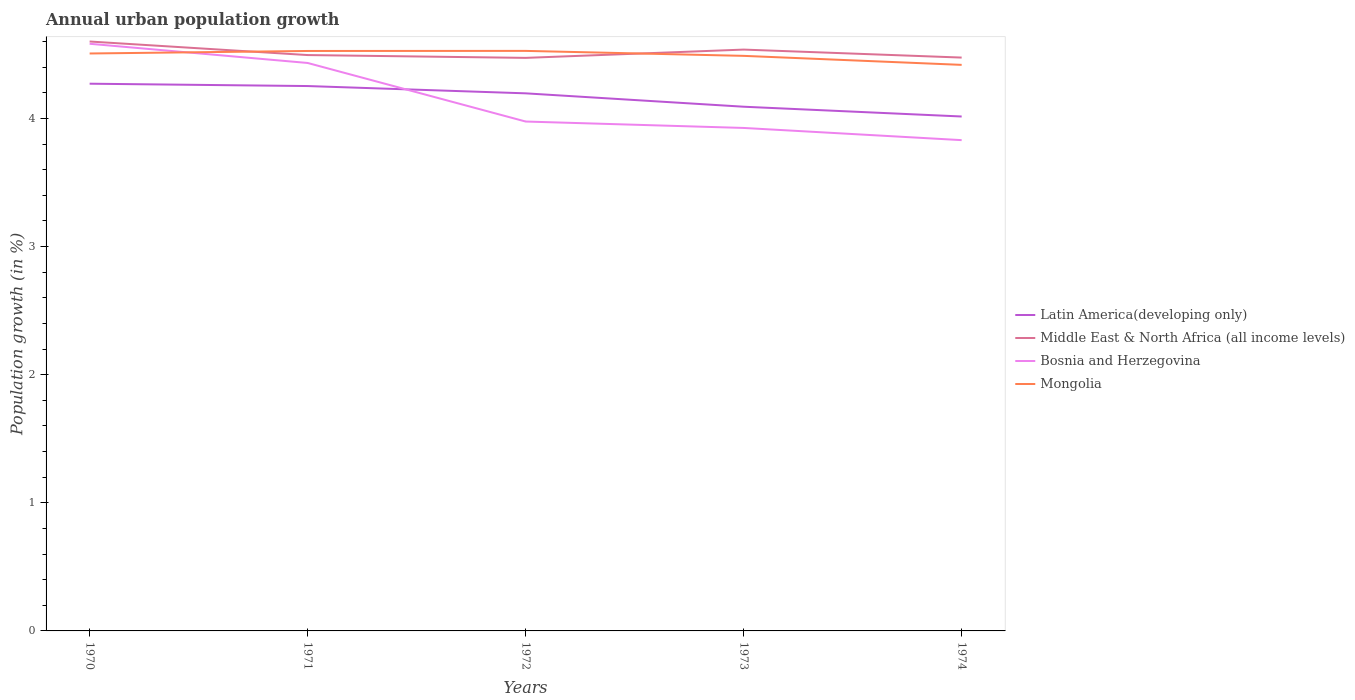Is the number of lines equal to the number of legend labels?
Keep it short and to the point. Yes. Across all years, what is the maximum percentage of urban population growth in Middle East & North Africa (all income levels)?
Provide a succinct answer. 4.47. In which year was the percentage of urban population growth in Mongolia maximum?
Give a very brief answer. 1974. What is the total percentage of urban population growth in Bosnia and Herzegovina in the graph?
Give a very brief answer. 0.6. What is the difference between the highest and the second highest percentage of urban population growth in Latin America(developing only)?
Make the answer very short. 0.26. What is the difference between the highest and the lowest percentage of urban population growth in Latin America(developing only)?
Provide a short and direct response. 3. How many lines are there?
Ensure brevity in your answer.  4. What is the difference between two consecutive major ticks on the Y-axis?
Ensure brevity in your answer.  1. How many legend labels are there?
Ensure brevity in your answer.  4. What is the title of the graph?
Offer a terse response. Annual urban population growth. What is the label or title of the Y-axis?
Your answer should be very brief. Population growth (in %). What is the Population growth (in %) in Latin America(developing only) in 1970?
Offer a terse response. 4.27. What is the Population growth (in %) of Middle East & North Africa (all income levels) in 1970?
Keep it short and to the point. 4.6. What is the Population growth (in %) of Bosnia and Herzegovina in 1970?
Provide a short and direct response. 4.58. What is the Population growth (in %) in Mongolia in 1970?
Offer a terse response. 4.51. What is the Population growth (in %) in Latin America(developing only) in 1971?
Your response must be concise. 4.25. What is the Population growth (in %) in Middle East & North Africa (all income levels) in 1971?
Your response must be concise. 4.49. What is the Population growth (in %) in Bosnia and Herzegovina in 1971?
Provide a short and direct response. 4.43. What is the Population growth (in %) of Mongolia in 1971?
Offer a very short reply. 4.53. What is the Population growth (in %) of Latin America(developing only) in 1972?
Provide a short and direct response. 4.2. What is the Population growth (in %) in Middle East & North Africa (all income levels) in 1972?
Provide a short and direct response. 4.47. What is the Population growth (in %) in Bosnia and Herzegovina in 1972?
Offer a very short reply. 3.98. What is the Population growth (in %) in Mongolia in 1972?
Make the answer very short. 4.53. What is the Population growth (in %) of Latin America(developing only) in 1973?
Make the answer very short. 4.09. What is the Population growth (in %) of Middle East & North Africa (all income levels) in 1973?
Your answer should be very brief. 4.54. What is the Population growth (in %) in Bosnia and Herzegovina in 1973?
Provide a succinct answer. 3.93. What is the Population growth (in %) in Mongolia in 1973?
Offer a terse response. 4.49. What is the Population growth (in %) in Latin America(developing only) in 1974?
Make the answer very short. 4.01. What is the Population growth (in %) in Middle East & North Africa (all income levels) in 1974?
Offer a terse response. 4.47. What is the Population growth (in %) in Bosnia and Herzegovina in 1974?
Provide a succinct answer. 3.83. What is the Population growth (in %) of Mongolia in 1974?
Make the answer very short. 4.42. Across all years, what is the maximum Population growth (in %) of Latin America(developing only)?
Keep it short and to the point. 4.27. Across all years, what is the maximum Population growth (in %) of Middle East & North Africa (all income levels)?
Your answer should be very brief. 4.6. Across all years, what is the maximum Population growth (in %) in Bosnia and Herzegovina?
Give a very brief answer. 4.58. Across all years, what is the maximum Population growth (in %) of Mongolia?
Make the answer very short. 4.53. Across all years, what is the minimum Population growth (in %) of Latin America(developing only)?
Provide a short and direct response. 4.01. Across all years, what is the minimum Population growth (in %) of Middle East & North Africa (all income levels)?
Provide a short and direct response. 4.47. Across all years, what is the minimum Population growth (in %) of Bosnia and Herzegovina?
Your response must be concise. 3.83. Across all years, what is the minimum Population growth (in %) of Mongolia?
Your answer should be compact. 4.42. What is the total Population growth (in %) in Latin America(developing only) in the graph?
Provide a short and direct response. 20.83. What is the total Population growth (in %) in Middle East & North Africa (all income levels) in the graph?
Offer a terse response. 22.58. What is the total Population growth (in %) of Bosnia and Herzegovina in the graph?
Your answer should be compact. 20.75. What is the total Population growth (in %) of Mongolia in the graph?
Your response must be concise. 22.47. What is the difference between the Population growth (in %) of Latin America(developing only) in 1970 and that in 1971?
Ensure brevity in your answer.  0.02. What is the difference between the Population growth (in %) of Middle East & North Africa (all income levels) in 1970 and that in 1971?
Make the answer very short. 0.11. What is the difference between the Population growth (in %) in Bosnia and Herzegovina in 1970 and that in 1971?
Offer a terse response. 0.15. What is the difference between the Population growth (in %) in Mongolia in 1970 and that in 1971?
Keep it short and to the point. -0.02. What is the difference between the Population growth (in %) in Latin America(developing only) in 1970 and that in 1972?
Offer a very short reply. 0.08. What is the difference between the Population growth (in %) of Middle East & North Africa (all income levels) in 1970 and that in 1972?
Give a very brief answer. 0.13. What is the difference between the Population growth (in %) in Bosnia and Herzegovina in 1970 and that in 1972?
Keep it short and to the point. 0.61. What is the difference between the Population growth (in %) in Mongolia in 1970 and that in 1972?
Your answer should be compact. -0.02. What is the difference between the Population growth (in %) in Latin America(developing only) in 1970 and that in 1973?
Provide a short and direct response. 0.18. What is the difference between the Population growth (in %) in Middle East & North Africa (all income levels) in 1970 and that in 1973?
Provide a short and direct response. 0.06. What is the difference between the Population growth (in %) of Bosnia and Herzegovina in 1970 and that in 1973?
Give a very brief answer. 0.66. What is the difference between the Population growth (in %) in Mongolia in 1970 and that in 1973?
Provide a succinct answer. 0.02. What is the difference between the Population growth (in %) in Latin America(developing only) in 1970 and that in 1974?
Keep it short and to the point. 0.26. What is the difference between the Population growth (in %) of Middle East & North Africa (all income levels) in 1970 and that in 1974?
Your answer should be very brief. 0.13. What is the difference between the Population growth (in %) of Bosnia and Herzegovina in 1970 and that in 1974?
Your response must be concise. 0.75. What is the difference between the Population growth (in %) of Mongolia in 1970 and that in 1974?
Keep it short and to the point. 0.09. What is the difference between the Population growth (in %) of Latin America(developing only) in 1971 and that in 1972?
Ensure brevity in your answer.  0.06. What is the difference between the Population growth (in %) in Middle East & North Africa (all income levels) in 1971 and that in 1972?
Give a very brief answer. 0.02. What is the difference between the Population growth (in %) of Bosnia and Herzegovina in 1971 and that in 1972?
Offer a very short reply. 0.46. What is the difference between the Population growth (in %) of Mongolia in 1971 and that in 1972?
Your answer should be compact. -0. What is the difference between the Population growth (in %) of Latin America(developing only) in 1971 and that in 1973?
Provide a short and direct response. 0.16. What is the difference between the Population growth (in %) of Middle East & North Africa (all income levels) in 1971 and that in 1973?
Keep it short and to the point. -0.04. What is the difference between the Population growth (in %) of Bosnia and Herzegovina in 1971 and that in 1973?
Make the answer very short. 0.51. What is the difference between the Population growth (in %) of Mongolia in 1971 and that in 1973?
Keep it short and to the point. 0.04. What is the difference between the Population growth (in %) in Latin America(developing only) in 1971 and that in 1974?
Ensure brevity in your answer.  0.24. What is the difference between the Population growth (in %) in Middle East & North Africa (all income levels) in 1971 and that in 1974?
Your response must be concise. 0.02. What is the difference between the Population growth (in %) of Bosnia and Herzegovina in 1971 and that in 1974?
Your response must be concise. 0.6. What is the difference between the Population growth (in %) of Mongolia in 1971 and that in 1974?
Your answer should be very brief. 0.11. What is the difference between the Population growth (in %) in Latin America(developing only) in 1972 and that in 1973?
Make the answer very short. 0.1. What is the difference between the Population growth (in %) in Middle East & North Africa (all income levels) in 1972 and that in 1973?
Ensure brevity in your answer.  -0.06. What is the difference between the Population growth (in %) of Mongolia in 1972 and that in 1973?
Give a very brief answer. 0.04. What is the difference between the Population growth (in %) of Latin America(developing only) in 1972 and that in 1974?
Your response must be concise. 0.18. What is the difference between the Population growth (in %) of Middle East & North Africa (all income levels) in 1972 and that in 1974?
Ensure brevity in your answer.  -0. What is the difference between the Population growth (in %) in Bosnia and Herzegovina in 1972 and that in 1974?
Your response must be concise. 0.15. What is the difference between the Population growth (in %) in Mongolia in 1972 and that in 1974?
Ensure brevity in your answer.  0.11. What is the difference between the Population growth (in %) in Latin America(developing only) in 1973 and that in 1974?
Make the answer very short. 0.08. What is the difference between the Population growth (in %) in Middle East & North Africa (all income levels) in 1973 and that in 1974?
Offer a terse response. 0.06. What is the difference between the Population growth (in %) of Bosnia and Herzegovina in 1973 and that in 1974?
Make the answer very short. 0.1. What is the difference between the Population growth (in %) of Mongolia in 1973 and that in 1974?
Give a very brief answer. 0.07. What is the difference between the Population growth (in %) in Latin America(developing only) in 1970 and the Population growth (in %) in Middle East & North Africa (all income levels) in 1971?
Ensure brevity in your answer.  -0.22. What is the difference between the Population growth (in %) of Latin America(developing only) in 1970 and the Population growth (in %) of Bosnia and Herzegovina in 1971?
Provide a short and direct response. -0.16. What is the difference between the Population growth (in %) of Latin America(developing only) in 1970 and the Population growth (in %) of Mongolia in 1971?
Make the answer very short. -0.26. What is the difference between the Population growth (in %) in Middle East & North Africa (all income levels) in 1970 and the Population growth (in %) in Bosnia and Herzegovina in 1971?
Ensure brevity in your answer.  0.17. What is the difference between the Population growth (in %) of Middle East & North Africa (all income levels) in 1970 and the Population growth (in %) of Mongolia in 1971?
Offer a very short reply. 0.07. What is the difference between the Population growth (in %) in Bosnia and Herzegovina in 1970 and the Population growth (in %) in Mongolia in 1971?
Your answer should be compact. 0.06. What is the difference between the Population growth (in %) in Latin America(developing only) in 1970 and the Population growth (in %) in Middle East & North Africa (all income levels) in 1972?
Your response must be concise. -0.2. What is the difference between the Population growth (in %) in Latin America(developing only) in 1970 and the Population growth (in %) in Bosnia and Herzegovina in 1972?
Make the answer very short. 0.3. What is the difference between the Population growth (in %) of Latin America(developing only) in 1970 and the Population growth (in %) of Mongolia in 1972?
Your answer should be compact. -0.26. What is the difference between the Population growth (in %) in Middle East & North Africa (all income levels) in 1970 and the Population growth (in %) in Bosnia and Herzegovina in 1972?
Your response must be concise. 0.62. What is the difference between the Population growth (in %) in Middle East & North Africa (all income levels) in 1970 and the Population growth (in %) in Mongolia in 1972?
Make the answer very short. 0.07. What is the difference between the Population growth (in %) of Bosnia and Herzegovina in 1970 and the Population growth (in %) of Mongolia in 1972?
Provide a succinct answer. 0.06. What is the difference between the Population growth (in %) in Latin America(developing only) in 1970 and the Population growth (in %) in Middle East & North Africa (all income levels) in 1973?
Make the answer very short. -0.27. What is the difference between the Population growth (in %) in Latin America(developing only) in 1970 and the Population growth (in %) in Bosnia and Herzegovina in 1973?
Make the answer very short. 0.35. What is the difference between the Population growth (in %) of Latin America(developing only) in 1970 and the Population growth (in %) of Mongolia in 1973?
Give a very brief answer. -0.22. What is the difference between the Population growth (in %) in Middle East & North Africa (all income levels) in 1970 and the Population growth (in %) in Bosnia and Herzegovina in 1973?
Offer a terse response. 0.67. What is the difference between the Population growth (in %) of Middle East & North Africa (all income levels) in 1970 and the Population growth (in %) of Mongolia in 1973?
Ensure brevity in your answer.  0.11. What is the difference between the Population growth (in %) of Bosnia and Herzegovina in 1970 and the Population growth (in %) of Mongolia in 1973?
Make the answer very short. 0.09. What is the difference between the Population growth (in %) in Latin America(developing only) in 1970 and the Population growth (in %) in Middle East & North Africa (all income levels) in 1974?
Ensure brevity in your answer.  -0.2. What is the difference between the Population growth (in %) of Latin America(developing only) in 1970 and the Population growth (in %) of Bosnia and Herzegovina in 1974?
Your answer should be compact. 0.44. What is the difference between the Population growth (in %) in Latin America(developing only) in 1970 and the Population growth (in %) in Mongolia in 1974?
Your answer should be very brief. -0.15. What is the difference between the Population growth (in %) in Middle East & North Africa (all income levels) in 1970 and the Population growth (in %) in Bosnia and Herzegovina in 1974?
Provide a short and direct response. 0.77. What is the difference between the Population growth (in %) of Middle East & North Africa (all income levels) in 1970 and the Population growth (in %) of Mongolia in 1974?
Your answer should be compact. 0.18. What is the difference between the Population growth (in %) of Bosnia and Herzegovina in 1970 and the Population growth (in %) of Mongolia in 1974?
Provide a short and direct response. 0.16. What is the difference between the Population growth (in %) in Latin America(developing only) in 1971 and the Population growth (in %) in Middle East & North Africa (all income levels) in 1972?
Ensure brevity in your answer.  -0.22. What is the difference between the Population growth (in %) in Latin America(developing only) in 1971 and the Population growth (in %) in Bosnia and Herzegovina in 1972?
Offer a very short reply. 0.28. What is the difference between the Population growth (in %) in Latin America(developing only) in 1971 and the Population growth (in %) in Mongolia in 1972?
Provide a short and direct response. -0.27. What is the difference between the Population growth (in %) in Middle East & North Africa (all income levels) in 1971 and the Population growth (in %) in Bosnia and Herzegovina in 1972?
Give a very brief answer. 0.52. What is the difference between the Population growth (in %) of Middle East & North Africa (all income levels) in 1971 and the Population growth (in %) of Mongolia in 1972?
Your answer should be compact. -0.03. What is the difference between the Population growth (in %) in Bosnia and Herzegovina in 1971 and the Population growth (in %) in Mongolia in 1972?
Offer a very short reply. -0.09. What is the difference between the Population growth (in %) of Latin America(developing only) in 1971 and the Population growth (in %) of Middle East & North Africa (all income levels) in 1973?
Offer a terse response. -0.28. What is the difference between the Population growth (in %) in Latin America(developing only) in 1971 and the Population growth (in %) in Bosnia and Herzegovina in 1973?
Provide a succinct answer. 0.33. What is the difference between the Population growth (in %) in Latin America(developing only) in 1971 and the Population growth (in %) in Mongolia in 1973?
Keep it short and to the point. -0.24. What is the difference between the Population growth (in %) of Middle East & North Africa (all income levels) in 1971 and the Population growth (in %) of Bosnia and Herzegovina in 1973?
Give a very brief answer. 0.57. What is the difference between the Population growth (in %) of Middle East & North Africa (all income levels) in 1971 and the Population growth (in %) of Mongolia in 1973?
Your answer should be very brief. 0.01. What is the difference between the Population growth (in %) of Bosnia and Herzegovina in 1971 and the Population growth (in %) of Mongolia in 1973?
Your answer should be compact. -0.06. What is the difference between the Population growth (in %) of Latin America(developing only) in 1971 and the Population growth (in %) of Middle East & North Africa (all income levels) in 1974?
Your response must be concise. -0.22. What is the difference between the Population growth (in %) in Latin America(developing only) in 1971 and the Population growth (in %) in Bosnia and Herzegovina in 1974?
Provide a succinct answer. 0.42. What is the difference between the Population growth (in %) in Latin America(developing only) in 1971 and the Population growth (in %) in Mongolia in 1974?
Offer a terse response. -0.17. What is the difference between the Population growth (in %) of Middle East & North Africa (all income levels) in 1971 and the Population growth (in %) of Bosnia and Herzegovina in 1974?
Offer a terse response. 0.66. What is the difference between the Population growth (in %) of Middle East & North Africa (all income levels) in 1971 and the Population growth (in %) of Mongolia in 1974?
Make the answer very short. 0.08. What is the difference between the Population growth (in %) in Bosnia and Herzegovina in 1971 and the Population growth (in %) in Mongolia in 1974?
Your answer should be compact. 0.01. What is the difference between the Population growth (in %) of Latin America(developing only) in 1972 and the Population growth (in %) of Middle East & North Africa (all income levels) in 1973?
Your answer should be very brief. -0.34. What is the difference between the Population growth (in %) in Latin America(developing only) in 1972 and the Population growth (in %) in Bosnia and Herzegovina in 1973?
Keep it short and to the point. 0.27. What is the difference between the Population growth (in %) in Latin America(developing only) in 1972 and the Population growth (in %) in Mongolia in 1973?
Offer a terse response. -0.29. What is the difference between the Population growth (in %) in Middle East & North Africa (all income levels) in 1972 and the Population growth (in %) in Bosnia and Herzegovina in 1973?
Ensure brevity in your answer.  0.55. What is the difference between the Population growth (in %) of Middle East & North Africa (all income levels) in 1972 and the Population growth (in %) of Mongolia in 1973?
Offer a very short reply. -0.02. What is the difference between the Population growth (in %) of Bosnia and Herzegovina in 1972 and the Population growth (in %) of Mongolia in 1973?
Provide a short and direct response. -0.51. What is the difference between the Population growth (in %) in Latin America(developing only) in 1972 and the Population growth (in %) in Middle East & North Africa (all income levels) in 1974?
Provide a short and direct response. -0.28. What is the difference between the Population growth (in %) in Latin America(developing only) in 1972 and the Population growth (in %) in Bosnia and Herzegovina in 1974?
Ensure brevity in your answer.  0.37. What is the difference between the Population growth (in %) of Latin America(developing only) in 1972 and the Population growth (in %) of Mongolia in 1974?
Offer a terse response. -0.22. What is the difference between the Population growth (in %) in Middle East & North Africa (all income levels) in 1972 and the Population growth (in %) in Bosnia and Herzegovina in 1974?
Give a very brief answer. 0.64. What is the difference between the Population growth (in %) in Middle East & North Africa (all income levels) in 1972 and the Population growth (in %) in Mongolia in 1974?
Ensure brevity in your answer.  0.05. What is the difference between the Population growth (in %) of Bosnia and Herzegovina in 1972 and the Population growth (in %) of Mongolia in 1974?
Provide a succinct answer. -0.44. What is the difference between the Population growth (in %) in Latin America(developing only) in 1973 and the Population growth (in %) in Middle East & North Africa (all income levels) in 1974?
Provide a short and direct response. -0.38. What is the difference between the Population growth (in %) in Latin America(developing only) in 1973 and the Population growth (in %) in Bosnia and Herzegovina in 1974?
Give a very brief answer. 0.26. What is the difference between the Population growth (in %) in Latin America(developing only) in 1973 and the Population growth (in %) in Mongolia in 1974?
Your answer should be compact. -0.33. What is the difference between the Population growth (in %) in Middle East & North Africa (all income levels) in 1973 and the Population growth (in %) in Bosnia and Herzegovina in 1974?
Provide a succinct answer. 0.71. What is the difference between the Population growth (in %) of Middle East & North Africa (all income levels) in 1973 and the Population growth (in %) of Mongolia in 1974?
Provide a succinct answer. 0.12. What is the difference between the Population growth (in %) of Bosnia and Herzegovina in 1973 and the Population growth (in %) of Mongolia in 1974?
Make the answer very short. -0.49. What is the average Population growth (in %) in Latin America(developing only) per year?
Offer a terse response. 4.17. What is the average Population growth (in %) of Middle East & North Africa (all income levels) per year?
Keep it short and to the point. 4.52. What is the average Population growth (in %) of Bosnia and Herzegovina per year?
Keep it short and to the point. 4.15. What is the average Population growth (in %) of Mongolia per year?
Provide a succinct answer. 4.49. In the year 1970, what is the difference between the Population growth (in %) in Latin America(developing only) and Population growth (in %) in Middle East & North Africa (all income levels)?
Your answer should be compact. -0.33. In the year 1970, what is the difference between the Population growth (in %) of Latin America(developing only) and Population growth (in %) of Bosnia and Herzegovina?
Keep it short and to the point. -0.31. In the year 1970, what is the difference between the Population growth (in %) of Latin America(developing only) and Population growth (in %) of Mongolia?
Offer a terse response. -0.24. In the year 1970, what is the difference between the Population growth (in %) of Middle East & North Africa (all income levels) and Population growth (in %) of Bosnia and Herzegovina?
Provide a succinct answer. 0.02. In the year 1970, what is the difference between the Population growth (in %) of Middle East & North Africa (all income levels) and Population growth (in %) of Mongolia?
Offer a terse response. 0.09. In the year 1970, what is the difference between the Population growth (in %) in Bosnia and Herzegovina and Population growth (in %) in Mongolia?
Your response must be concise. 0.08. In the year 1971, what is the difference between the Population growth (in %) in Latin America(developing only) and Population growth (in %) in Middle East & North Africa (all income levels)?
Offer a terse response. -0.24. In the year 1971, what is the difference between the Population growth (in %) of Latin America(developing only) and Population growth (in %) of Bosnia and Herzegovina?
Your answer should be compact. -0.18. In the year 1971, what is the difference between the Population growth (in %) in Latin America(developing only) and Population growth (in %) in Mongolia?
Your answer should be compact. -0.27. In the year 1971, what is the difference between the Population growth (in %) in Middle East & North Africa (all income levels) and Population growth (in %) in Bosnia and Herzegovina?
Offer a very short reply. 0.06. In the year 1971, what is the difference between the Population growth (in %) in Middle East & North Africa (all income levels) and Population growth (in %) in Mongolia?
Keep it short and to the point. -0.03. In the year 1971, what is the difference between the Population growth (in %) of Bosnia and Herzegovina and Population growth (in %) of Mongolia?
Make the answer very short. -0.09. In the year 1972, what is the difference between the Population growth (in %) in Latin America(developing only) and Population growth (in %) in Middle East & North Africa (all income levels)?
Your answer should be compact. -0.28. In the year 1972, what is the difference between the Population growth (in %) in Latin America(developing only) and Population growth (in %) in Bosnia and Herzegovina?
Offer a very short reply. 0.22. In the year 1972, what is the difference between the Population growth (in %) of Latin America(developing only) and Population growth (in %) of Mongolia?
Offer a very short reply. -0.33. In the year 1972, what is the difference between the Population growth (in %) in Middle East & North Africa (all income levels) and Population growth (in %) in Bosnia and Herzegovina?
Your response must be concise. 0.5. In the year 1972, what is the difference between the Population growth (in %) in Middle East & North Africa (all income levels) and Population growth (in %) in Mongolia?
Ensure brevity in your answer.  -0.05. In the year 1972, what is the difference between the Population growth (in %) of Bosnia and Herzegovina and Population growth (in %) of Mongolia?
Offer a terse response. -0.55. In the year 1973, what is the difference between the Population growth (in %) in Latin America(developing only) and Population growth (in %) in Middle East & North Africa (all income levels)?
Your answer should be very brief. -0.45. In the year 1973, what is the difference between the Population growth (in %) of Latin America(developing only) and Population growth (in %) of Bosnia and Herzegovina?
Your answer should be very brief. 0.17. In the year 1973, what is the difference between the Population growth (in %) of Latin America(developing only) and Population growth (in %) of Mongolia?
Provide a succinct answer. -0.4. In the year 1973, what is the difference between the Population growth (in %) in Middle East & North Africa (all income levels) and Population growth (in %) in Bosnia and Herzegovina?
Your answer should be very brief. 0.61. In the year 1973, what is the difference between the Population growth (in %) in Middle East & North Africa (all income levels) and Population growth (in %) in Mongolia?
Keep it short and to the point. 0.05. In the year 1973, what is the difference between the Population growth (in %) in Bosnia and Herzegovina and Population growth (in %) in Mongolia?
Provide a short and direct response. -0.56. In the year 1974, what is the difference between the Population growth (in %) in Latin America(developing only) and Population growth (in %) in Middle East & North Africa (all income levels)?
Keep it short and to the point. -0.46. In the year 1974, what is the difference between the Population growth (in %) of Latin America(developing only) and Population growth (in %) of Bosnia and Herzegovina?
Your answer should be very brief. 0.18. In the year 1974, what is the difference between the Population growth (in %) of Latin America(developing only) and Population growth (in %) of Mongolia?
Offer a terse response. -0.4. In the year 1974, what is the difference between the Population growth (in %) in Middle East & North Africa (all income levels) and Population growth (in %) in Bosnia and Herzegovina?
Keep it short and to the point. 0.64. In the year 1974, what is the difference between the Population growth (in %) of Middle East & North Africa (all income levels) and Population growth (in %) of Mongolia?
Keep it short and to the point. 0.06. In the year 1974, what is the difference between the Population growth (in %) in Bosnia and Herzegovina and Population growth (in %) in Mongolia?
Your answer should be compact. -0.59. What is the ratio of the Population growth (in %) in Latin America(developing only) in 1970 to that in 1971?
Your answer should be compact. 1. What is the ratio of the Population growth (in %) of Middle East & North Africa (all income levels) in 1970 to that in 1971?
Give a very brief answer. 1.02. What is the ratio of the Population growth (in %) of Bosnia and Herzegovina in 1970 to that in 1971?
Ensure brevity in your answer.  1.03. What is the ratio of the Population growth (in %) of Latin America(developing only) in 1970 to that in 1972?
Provide a short and direct response. 1.02. What is the ratio of the Population growth (in %) of Middle East & North Africa (all income levels) in 1970 to that in 1972?
Offer a very short reply. 1.03. What is the ratio of the Population growth (in %) in Bosnia and Herzegovina in 1970 to that in 1972?
Offer a very short reply. 1.15. What is the ratio of the Population growth (in %) of Mongolia in 1970 to that in 1972?
Provide a succinct answer. 1. What is the ratio of the Population growth (in %) in Latin America(developing only) in 1970 to that in 1973?
Make the answer very short. 1.04. What is the ratio of the Population growth (in %) of Middle East & North Africa (all income levels) in 1970 to that in 1973?
Keep it short and to the point. 1.01. What is the ratio of the Population growth (in %) of Bosnia and Herzegovina in 1970 to that in 1973?
Keep it short and to the point. 1.17. What is the ratio of the Population growth (in %) of Latin America(developing only) in 1970 to that in 1974?
Provide a succinct answer. 1.06. What is the ratio of the Population growth (in %) in Middle East & North Africa (all income levels) in 1970 to that in 1974?
Your response must be concise. 1.03. What is the ratio of the Population growth (in %) in Bosnia and Herzegovina in 1970 to that in 1974?
Give a very brief answer. 1.2. What is the ratio of the Population growth (in %) in Mongolia in 1970 to that in 1974?
Your answer should be compact. 1.02. What is the ratio of the Population growth (in %) in Latin America(developing only) in 1971 to that in 1972?
Your answer should be very brief. 1.01. What is the ratio of the Population growth (in %) in Middle East & North Africa (all income levels) in 1971 to that in 1972?
Ensure brevity in your answer.  1. What is the ratio of the Population growth (in %) in Bosnia and Herzegovina in 1971 to that in 1972?
Your answer should be very brief. 1.11. What is the ratio of the Population growth (in %) in Latin America(developing only) in 1971 to that in 1973?
Ensure brevity in your answer.  1.04. What is the ratio of the Population growth (in %) in Middle East & North Africa (all income levels) in 1971 to that in 1973?
Ensure brevity in your answer.  0.99. What is the ratio of the Population growth (in %) of Bosnia and Herzegovina in 1971 to that in 1973?
Offer a very short reply. 1.13. What is the ratio of the Population growth (in %) of Mongolia in 1971 to that in 1973?
Provide a short and direct response. 1.01. What is the ratio of the Population growth (in %) in Latin America(developing only) in 1971 to that in 1974?
Offer a very short reply. 1.06. What is the ratio of the Population growth (in %) in Bosnia and Herzegovina in 1971 to that in 1974?
Provide a short and direct response. 1.16. What is the ratio of the Population growth (in %) in Mongolia in 1971 to that in 1974?
Make the answer very short. 1.02. What is the ratio of the Population growth (in %) of Latin America(developing only) in 1972 to that in 1973?
Your answer should be very brief. 1.03. What is the ratio of the Population growth (in %) in Middle East & North Africa (all income levels) in 1972 to that in 1973?
Your answer should be compact. 0.99. What is the ratio of the Population growth (in %) in Bosnia and Herzegovina in 1972 to that in 1973?
Offer a terse response. 1.01. What is the ratio of the Population growth (in %) in Mongolia in 1972 to that in 1973?
Provide a short and direct response. 1.01. What is the ratio of the Population growth (in %) in Latin America(developing only) in 1972 to that in 1974?
Your answer should be compact. 1.04. What is the ratio of the Population growth (in %) of Bosnia and Herzegovina in 1972 to that in 1974?
Offer a terse response. 1.04. What is the ratio of the Population growth (in %) in Mongolia in 1972 to that in 1974?
Your answer should be very brief. 1.02. What is the ratio of the Population growth (in %) in Latin America(developing only) in 1973 to that in 1974?
Offer a very short reply. 1.02. What is the ratio of the Population growth (in %) of Middle East & North Africa (all income levels) in 1973 to that in 1974?
Give a very brief answer. 1.01. What is the ratio of the Population growth (in %) in Bosnia and Herzegovina in 1973 to that in 1974?
Your response must be concise. 1.02. What is the ratio of the Population growth (in %) in Mongolia in 1973 to that in 1974?
Provide a succinct answer. 1.02. What is the difference between the highest and the second highest Population growth (in %) in Latin America(developing only)?
Make the answer very short. 0.02. What is the difference between the highest and the second highest Population growth (in %) of Middle East & North Africa (all income levels)?
Your answer should be very brief. 0.06. What is the difference between the highest and the second highest Population growth (in %) in Bosnia and Herzegovina?
Ensure brevity in your answer.  0.15. What is the difference between the highest and the second highest Population growth (in %) of Mongolia?
Offer a terse response. 0. What is the difference between the highest and the lowest Population growth (in %) in Latin America(developing only)?
Your response must be concise. 0.26. What is the difference between the highest and the lowest Population growth (in %) of Middle East & North Africa (all income levels)?
Your answer should be compact. 0.13. What is the difference between the highest and the lowest Population growth (in %) of Bosnia and Herzegovina?
Make the answer very short. 0.75. What is the difference between the highest and the lowest Population growth (in %) of Mongolia?
Keep it short and to the point. 0.11. 